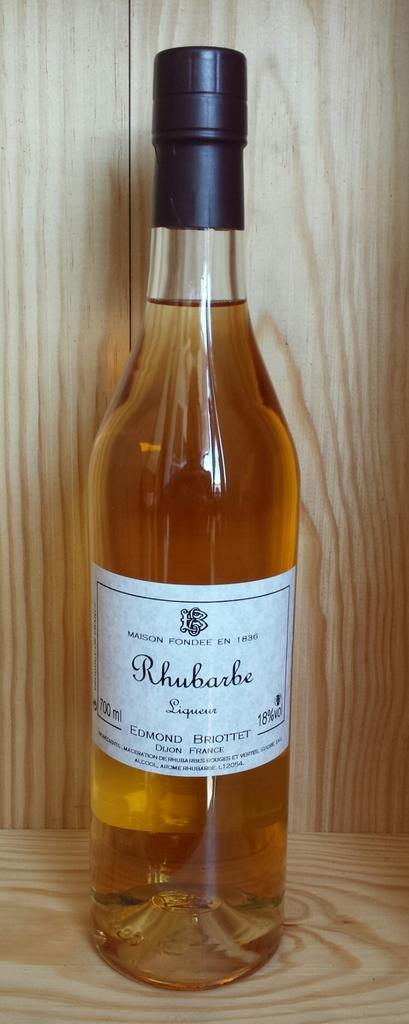<image>
Present a compact description of the photo's key features. A bottle of Rhubarbe LIqueuer with 18% alcohol is displayed in a wooden case. 